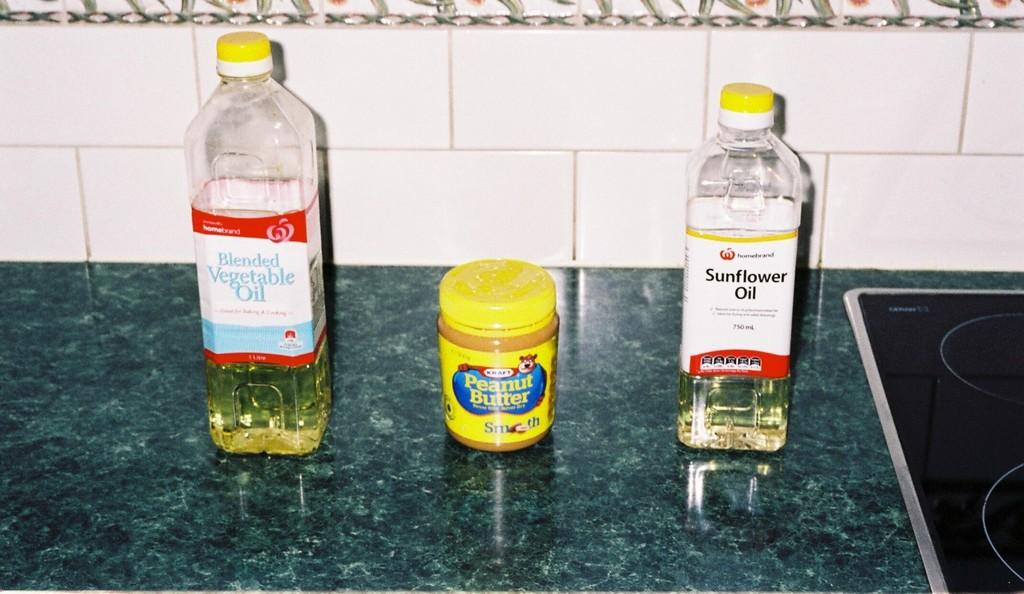<image>
Share a concise interpretation of the image provided. A jar of Kraft peanut butter sits between two bottles of cooking oil. 